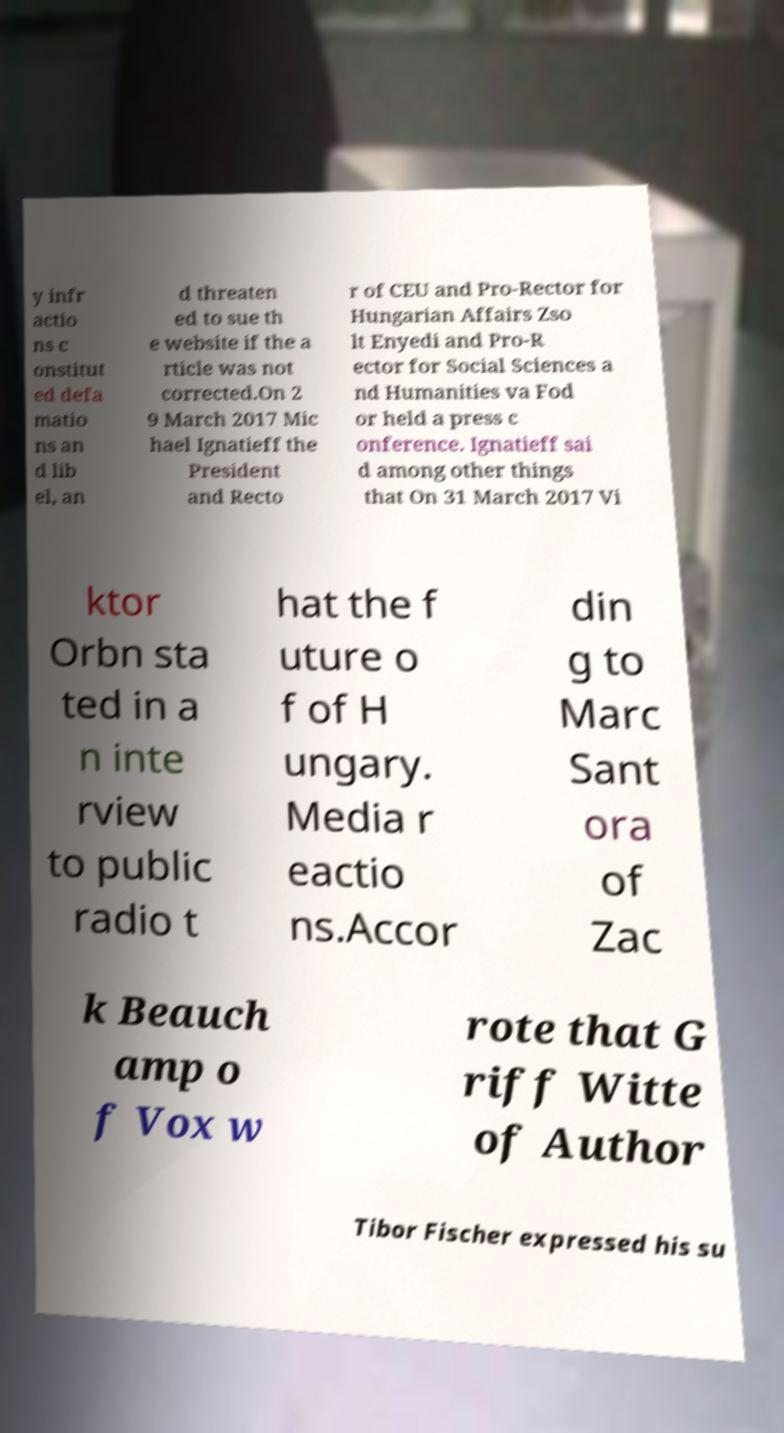Could you extract and type out the text from this image? y infr actio ns c onstitut ed defa matio ns an d lib el, an d threaten ed to sue th e website if the a rticle was not corrected.On 2 9 March 2017 Mic hael Ignatieff the President and Recto r of CEU and Pro-Rector for Hungarian Affairs Zso lt Enyedi and Pro-R ector for Social Sciences a nd Humanities va Fod or held a press c onference. Ignatieff sai d among other things that On 31 March 2017 Vi ktor Orbn sta ted in a n inte rview to public radio t hat the f uture o f of H ungary. Media r eactio ns.Accor din g to Marc Sant ora of Zac k Beauch amp o f Vox w rote that G riff Witte of Author Tibor Fischer expressed his su 